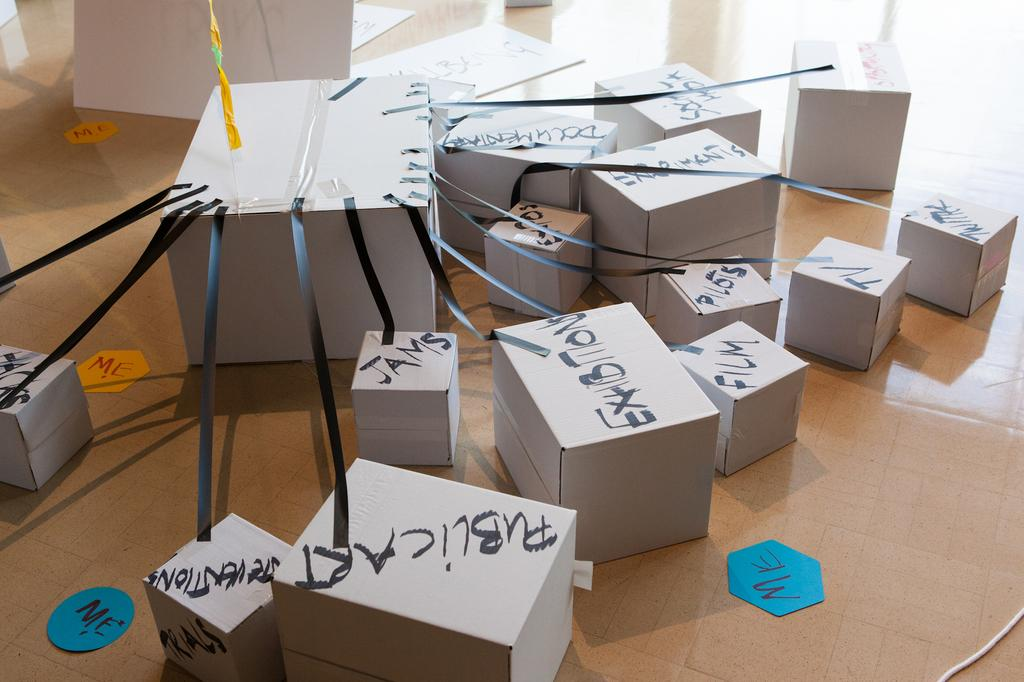<image>
Share a concise interpretation of the image provided. a bunch of white boxes on the ground 'publicart' 